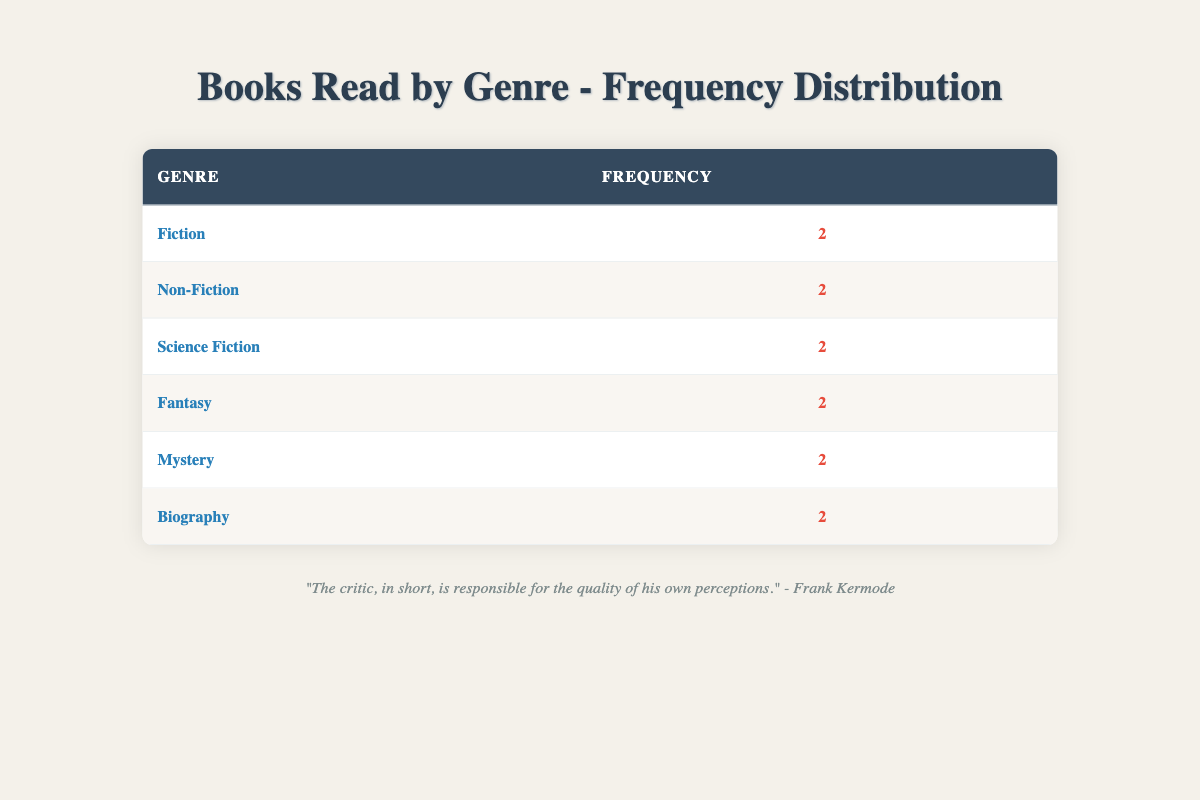What is the frequency of the Fiction genre? The table shows that the frequency for the Fiction genre is 2, as indicated in the 'Frequency' column next to the 'Fiction' row.
Answer: 2 How many genres have the same frequency as Biography? The table indicates that the Biography genre has a frequency of 2. Looking through the table, the genres with the same frequency of 2 include Fiction, Non-Fiction, Science Fiction, Fantasy, and Mystery. This results in a total of 6 genres sharing this frequency.
Answer: 6 Is there a genre where the frequency is higher than 3? Examining the table, each genre listed has a frequency of 2. Since no genre has a frequency higher than 3, the answer is no.
Answer: No Which genres have been read equally in the last year? The table shows each genre has a frequency of 2, hence all genres have been read equally. The genres include Fiction, Non-Fiction, Science Fiction, Fantasy, Mystery, and Biography, all with a frequency of 2.
Answer: All genres How many more genres have the same frequency as Mystery compared to those with a frequency of 1? The Mystery genre has a frequency of 2. Since all genres in the table have a frequency of 2, no genres have a frequency of 1. Therefore, the difference is 6 genres with frequency 2 compared to 0 genres with frequency 1, totaling 6.
Answer: 6 Which genre is among the least read based on the frequency? All genres have an equal frequency of 2. Hence, no genre can be singled out as the least read since they all have the same frequency.
Answer: None What is the sum of the frequencies of all genres? To get the sum of the frequencies, add up each frequency: 2 (Fiction) + 2 (Non-Fiction) + 2 (Science Fiction) + 2 (Fantasy) + 2 (Mystery) + 2 (Biography) = 12.
Answer: 12 Is the number of Science Fiction books read the same as the number of Biography books read? Both the Science Fiction and Biography genres have the same frequency of 2, which means they are equal. The answer to the question is yes.
Answer: Yes 